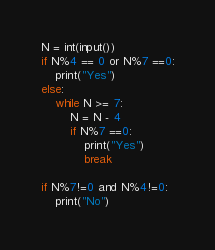Convert code to text. <code><loc_0><loc_0><loc_500><loc_500><_Python_>N = int(input())
if N%4 == 0 or N%7 ==0:
    print("Yes")
else:
    while N >= 7:
        N = N - 4
        if N%7 ==0:
            print("Yes")
            break
            
if N%7!=0 and N%4!=0:
    print("No")</code> 